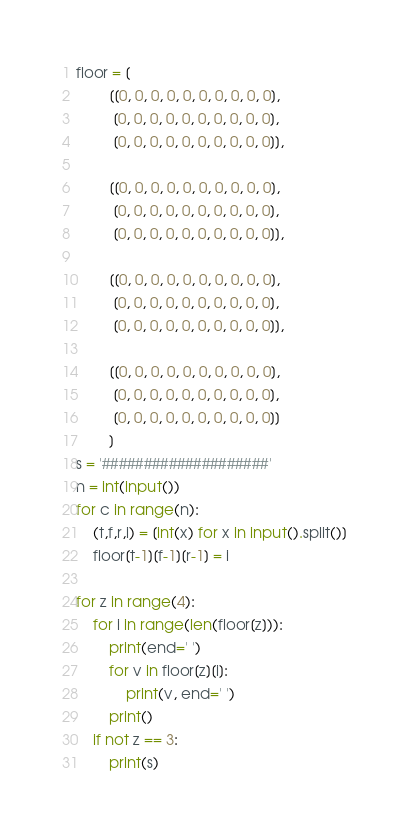<code> <loc_0><loc_0><loc_500><loc_500><_Python_>floor = [
        [[0, 0, 0, 0, 0, 0, 0, 0, 0, 0],
         [0, 0, 0, 0, 0, 0, 0, 0, 0, 0],
         [0, 0, 0, 0, 0, 0, 0, 0, 0, 0]],

        [[0, 0, 0, 0, 0, 0, 0, 0, 0, 0],
         [0, 0, 0, 0, 0, 0, 0, 0, 0, 0],
         [0, 0, 0, 0, 0, 0, 0, 0, 0, 0]],

        [[0, 0, 0, 0, 0, 0, 0, 0, 0, 0],
         [0, 0, 0, 0, 0, 0, 0, 0, 0, 0],
         [0, 0, 0, 0, 0, 0, 0, 0, 0, 0]],

        [[0, 0, 0, 0, 0, 0, 0, 0, 0, 0],
         [0, 0, 0, 0, 0, 0, 0, 0, 0, 0],
         [0, 0, 0, 0, 0, 0, 0, 0, 0, 0]]
        ]
s = '####################'
n = int(input())
for c in range(n):
    (t,f,r,i) = [int(x) for x in input().split()]
    floor[t-1][f-1][r-1] = i

for z in range(4):
    for i in range(len(floor[z])):
        print(end=' ')
        for v in floor[z][i]:
            print(v, end=' ')
        print()
    if not z == 3:
        print(s)</code> 